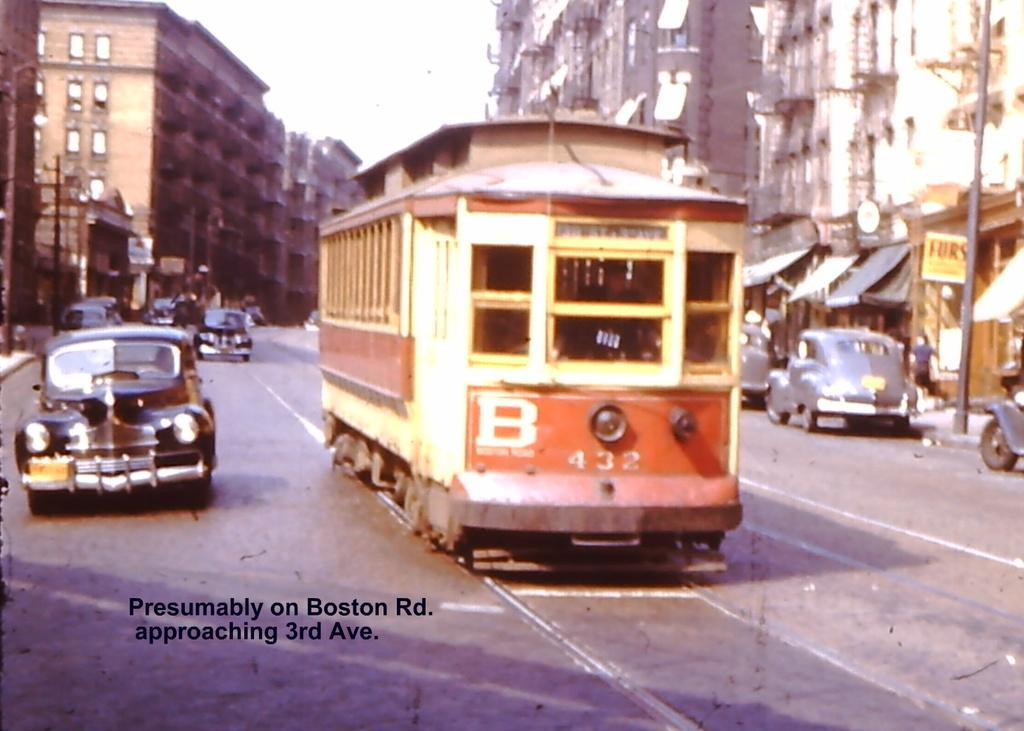<image>
Present a compact description of the photo's key features. A B 432 trolley driving on Boston Road and approaching 3rd avenue 